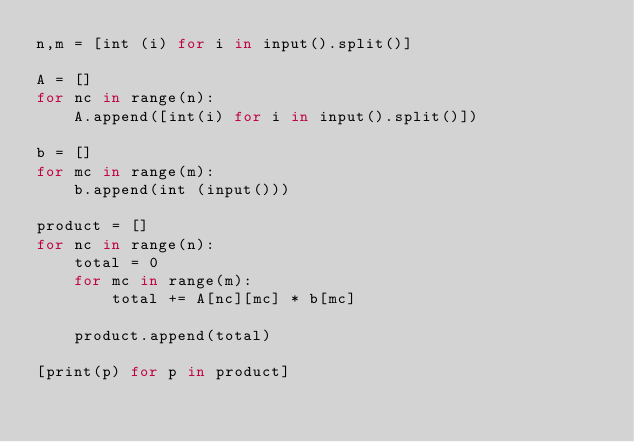<code> <loc_0><loc_0><loc_500><loc_500><_JavaScript_>n,m = [int (i) for i in input().split()]

A = []
for nc in range(n):
    A.append([int(i) for i in input().split()])

b = []
for mc in range(m):
    b.append(int (input()))

product = []
for nc in range(n):
    total = 0
    for mc in range(m):
        total += A[nc][mc] * b[mc]

    product.append(total)

[print(p) for p in product]</code> 